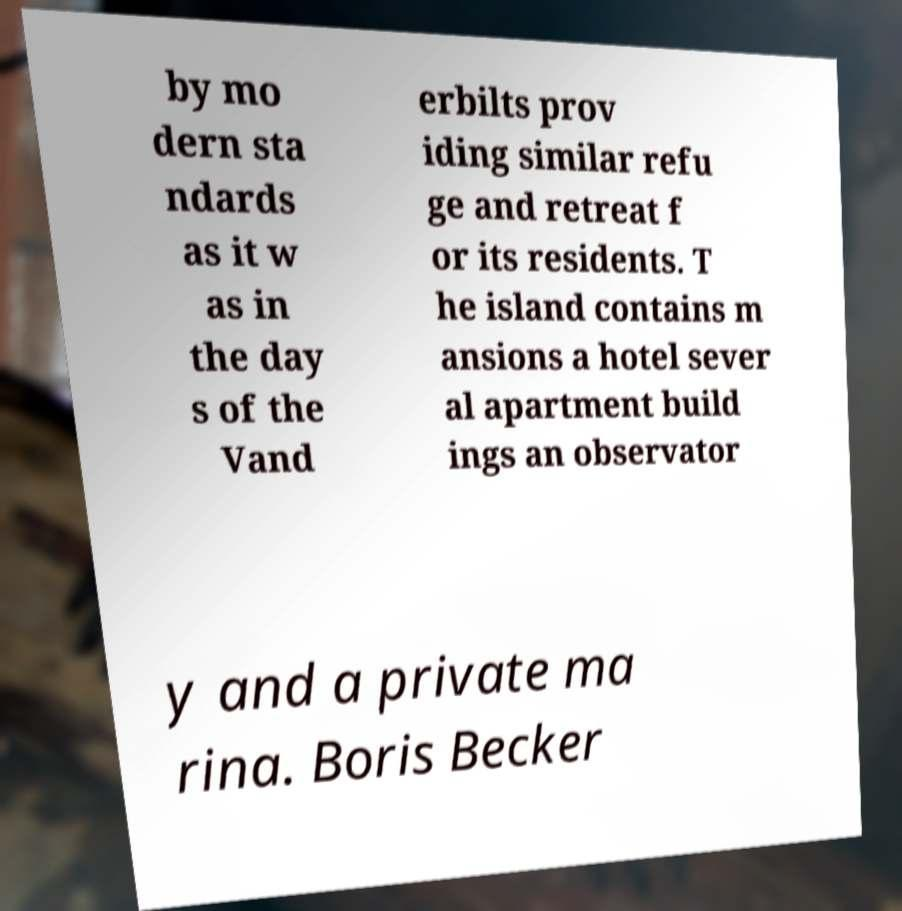Could you extract and type out the text from this image? by mo dern sta ndards as it w as in the day s of the Vand erbilts prov iding similar refu ge and retreat f or its residents. T he island contains m ansions a hotel sever al apartment build ings an observator y and a private ma rina. Boris Becker 